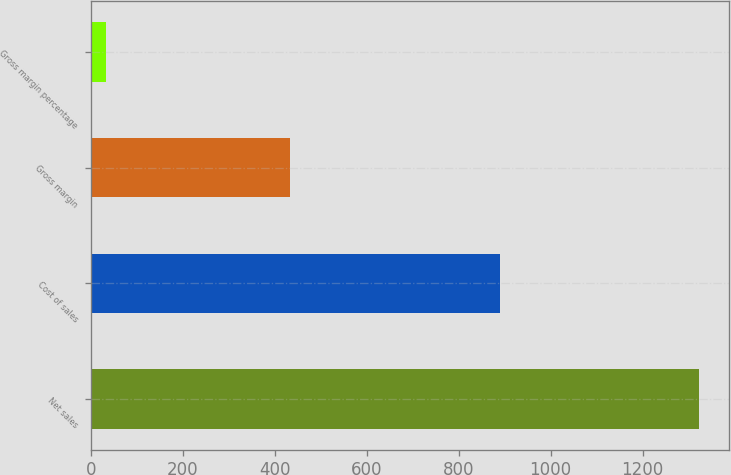Convert chart. <chart><loc_0><loc_0><loc_500><loc_500><bar_chart><fcel>Net sales<fcel>Cost of sales<fcel>Gross margin<fcel>Gross margin percentage<nl><fcel>1322<fcel>889<fcel>433<fcel>32.8<nl></chart> 